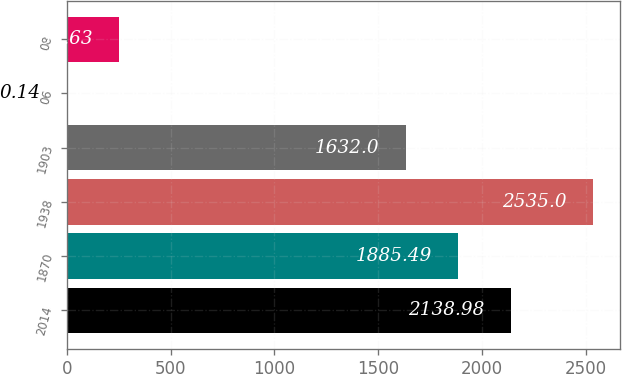Convert chart to OTSL. <chart><loc_0><loc_0><loc_500><loc_500><bar_chart><fcel>2014<fcel>1870<fcel>1938<fcel>1903<fcel>06<fcel>08<nl><fcel>2138.98<fcel>1885.49<fcel>2535<fcel>1632<fcel>0.14<fcel>253.63<nl></chart> 